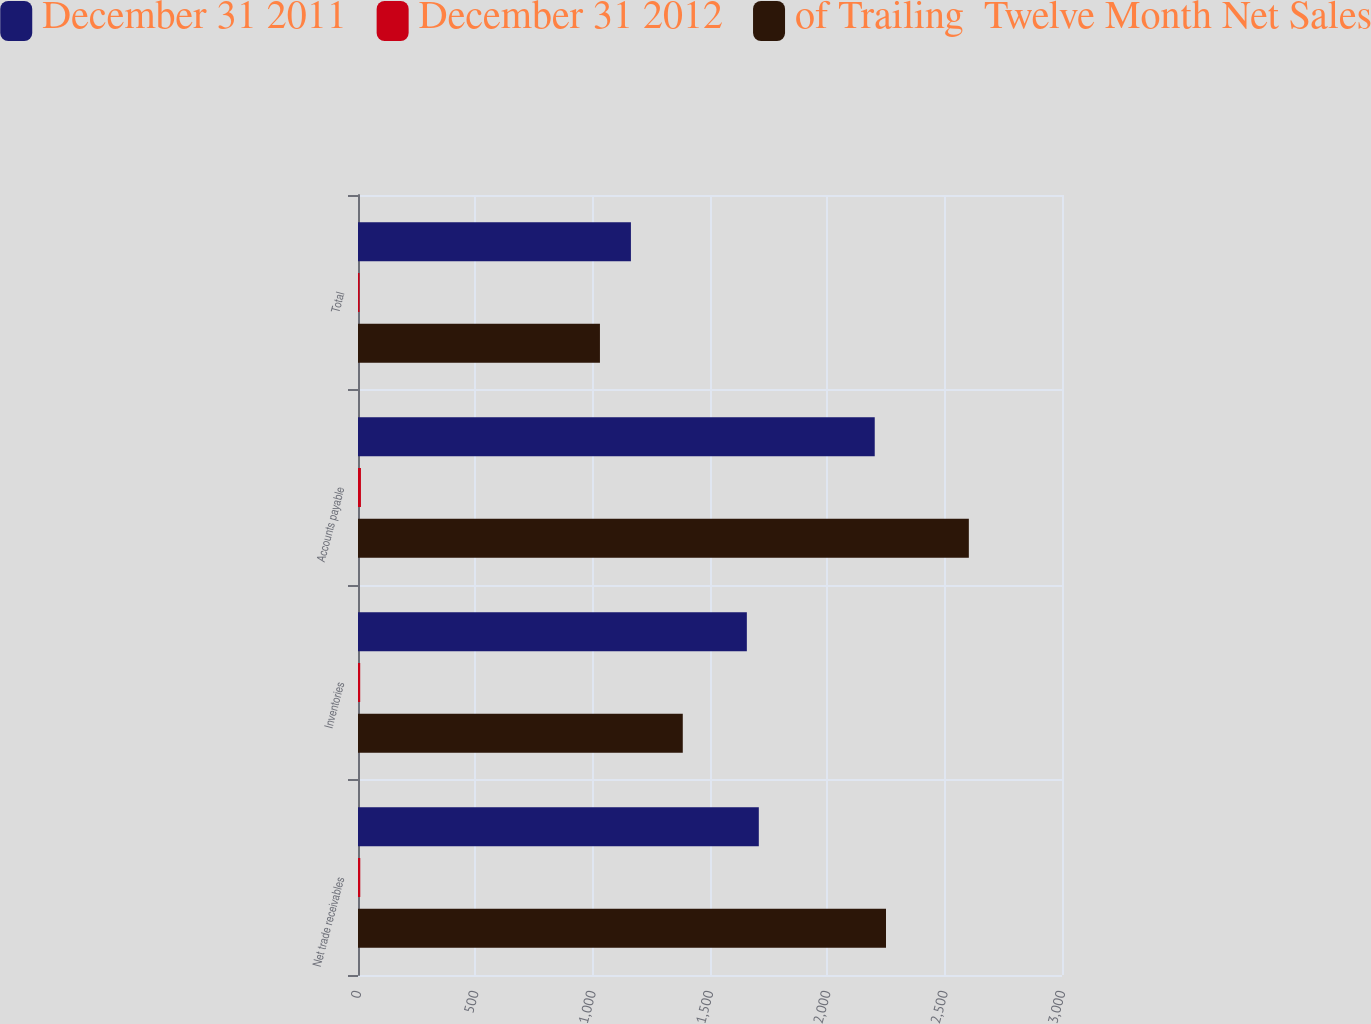Convert chart. <chart><loc_0><loc_0><loc_500><loc_500><stacked_bar_chart><ecel><fcel>Net trade receivables<fcel>Inventories<fcel>Accounts payable<fcel>Total<nl><fcel>December 31 2011<fcel>1708<fcel>1657<fcel>2202<fcel>1163<nl><fcel>December 31 2012<fcel>9.7<fcel>9.4<fcel>12.5<fcel>6.6<nl><fcel>of Trailing  Twelve Month Net Sales<fcel>2250<fcel>1384<fcel>2603<fcel>1031<nl></chart> 